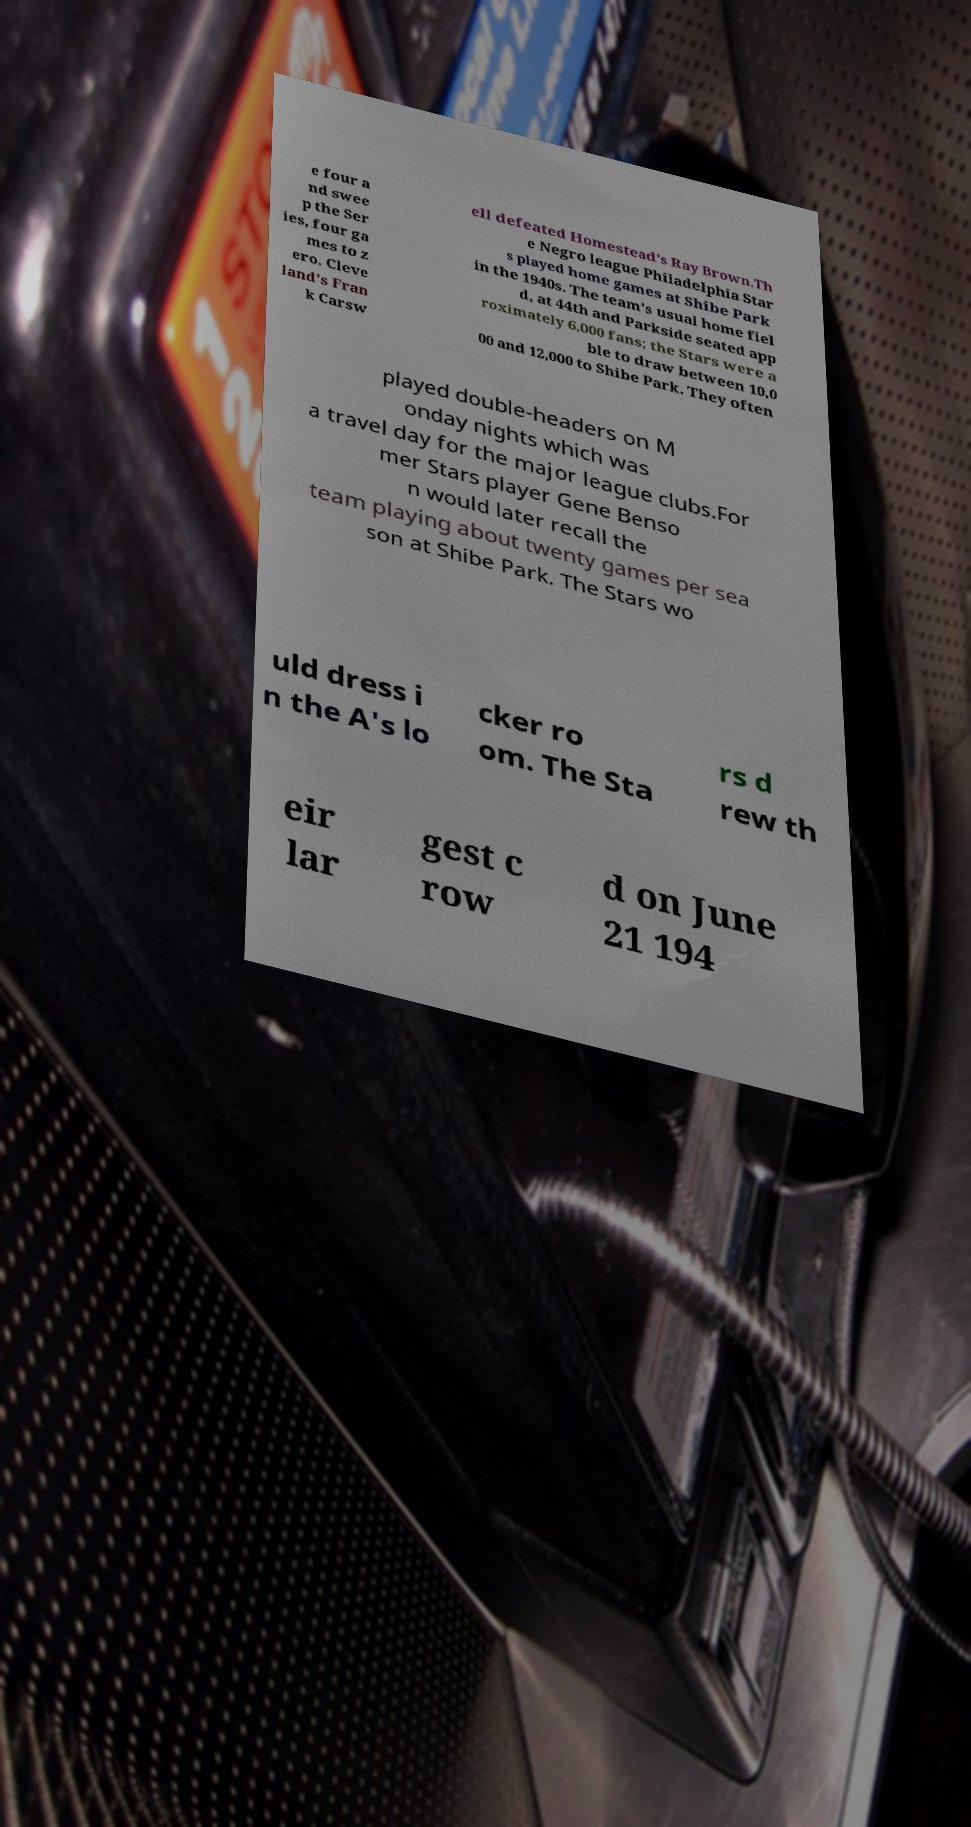Can you accurately transcribe the text from the provided image for me? e four a nd swee p the Ser ies, four ga mes to z ero. Cleve land's Fran k Carsw ell defeated Homestead's Ray Brown.Th e Negro league Philadelphia Star s played home games at Shibe Park in the 1940s. The team's usual home fiel d, at 44th and Parkside seated app roximately 6,000 fans; the Stars were a ble to draw between 10,0 00 and 12,000 to Shibe Park. They often played double-headers on M onday nights which was a travel day for the major league clubs.For mer Stars player Gene Benso n would later recall the team playing about twenty games per sea son at Shibe Park. The Stars wo uld dress i n the A's lo cker ro om. The Sta rs d rew th eir lar gest c row d on June 21 194 